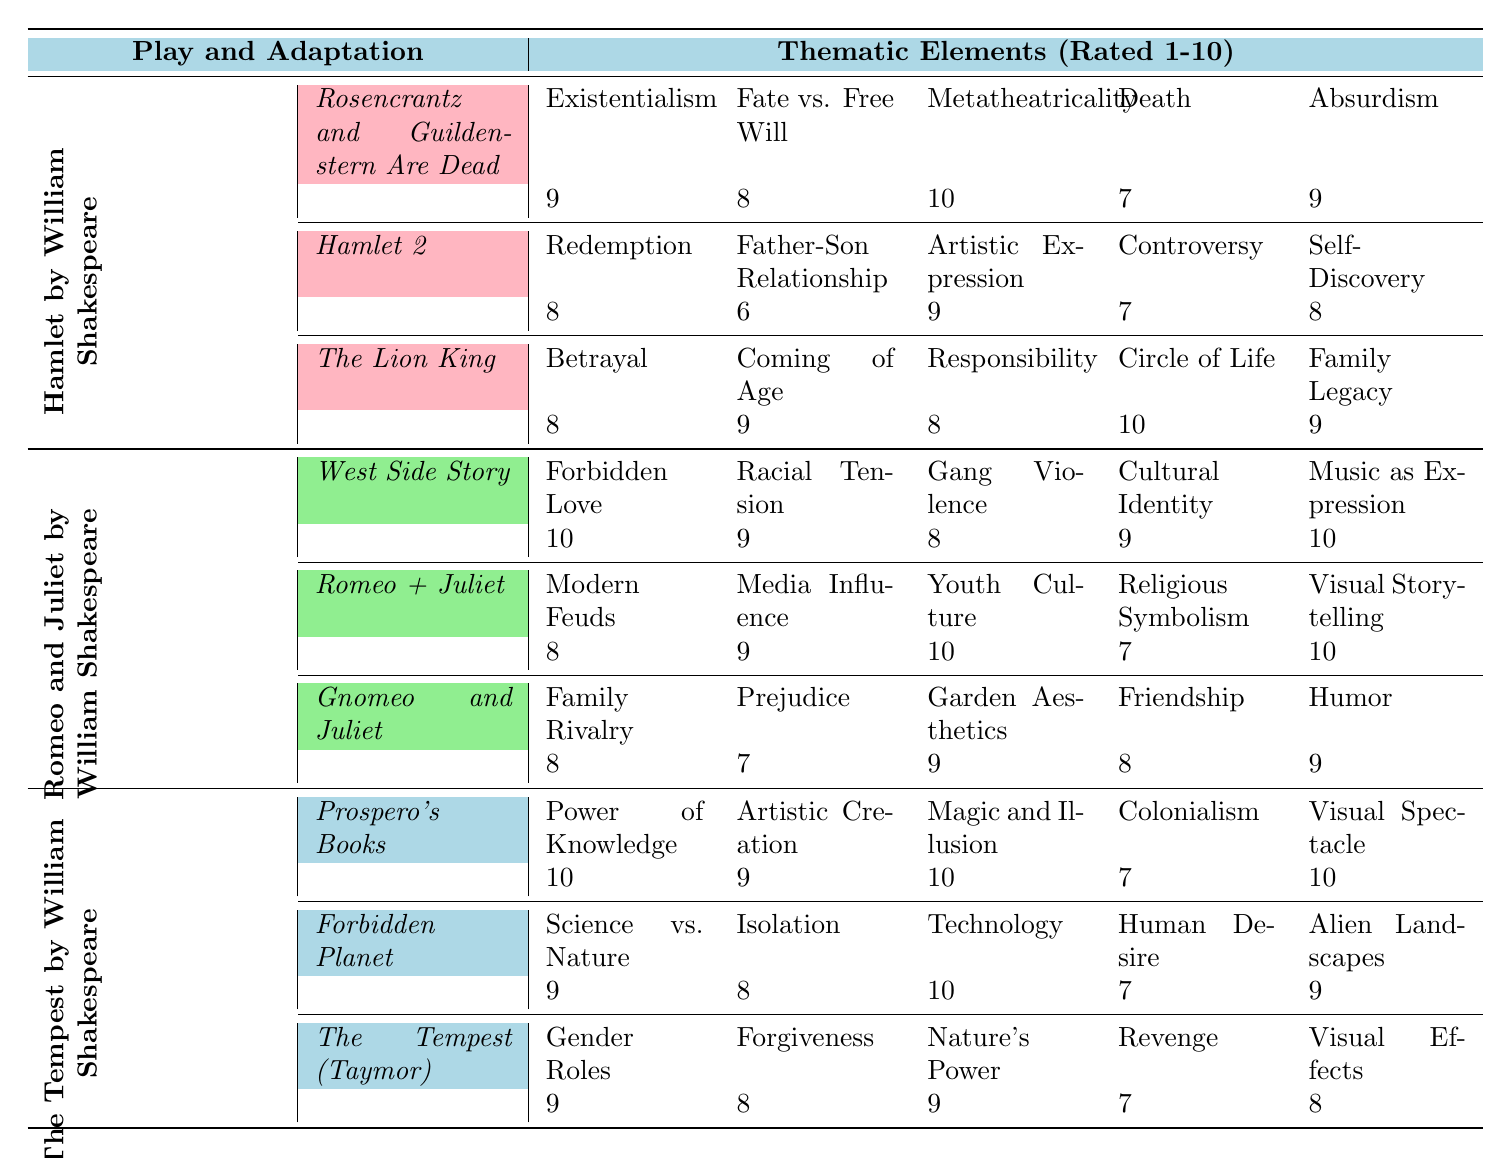What is the highest thematic rating for "Existentialism" in the adaptations of "Hamlet"? In the adaptations of "Hamlet," "Rosencrantz and Guildenstern Are Dead" has a rating of 9 for "Existentialism," which is the highest score among the adaptations.
Answer: 9 Which adaptation of "Romeo and Juliet" has the lowest rating for "Gang Violence"? The adaptation "Gnomeo and Juliet" has a rating of 8 for "Gang Violence," which is lower than the ratings of "West Side Story" (8) and "Romeo + Juliet" (10).
Answer: 8 What is the average rating for the thematic element "Family Legacy" across the adaptations of "Hamlet"? The ratings for "Family Legacy" in "Hamlet" adaptations are 9 (The Lion King), while other adaptations do not address it. Since there's only one rating, the average is simply 9 divided by 1, which is 9.
Answer: 9 Does "Forbidden Planet," an adaptation of "The Tempest," rate higher for "Technology" compared to "Human Desire"? "Forbidden Planet" has a rating of 10 for "Technology" and a rating of 7 for "Human Desire," so it rates higher for "Technology."
Answer: Yes What is the total thematic rating score for "Power of Knowledge" from the adaptations of "The Tempest"? The only adaptation that includes "Power of Knowledge" is "Prospero's Books," and it has a rating of 10. Therefore, the total score for this thematic element is 10.
Answer: 10 How do the ratings for "Racial Tension" in "West Side Story" compare to "Media Influence" in "Romeo + Juliet"? "West Side Story" has a rating of 9 for "Racial Tension," while "Romeo + Juliet" has a rating of 9 for "Media Influence." The ratings are equal between the two adaptations.
Answer: Equal (9) Which adaptation of "The Tempest" has the highest rating for "Visual Spectacle"? "Prospero's Books" has a rating of 10 for "Visual Spectacle," which is the highest among the adaptations of "The Tempest."
Answer: Prospero's Books What are the thematic element ratings for "Self-Discovery" and "Controversy" in "Hamlet 2," and which is higher? "Hamlet 2" has a rating of 8 for "Self-Discovery" and 7 for "Controversy." Comparing the two, "Self-Discovery" (8) is higher than "Controversy" (7).
Answer: Self-Discovery is higher What is the average rating of all thematic elements in "Rosencrantz and Guildenstern Are Dead"? The ratings for the thematic elements are 9, 8, 10, 7, and 9. Summing these gives 43, and there are 5 ratings, so the average is 43 divided by 5, which is 8.6.
Answer: 8.6 Is "Circle of Life" rated the highest among the thematic elements in "The Lion King"? "Circle of Life" is rated 10, which is the highest compared to other thematic elements in "The Lion King," such as Betrayal (8), Coming of Age (9), and Responsibility (8).
Answer: Yes 